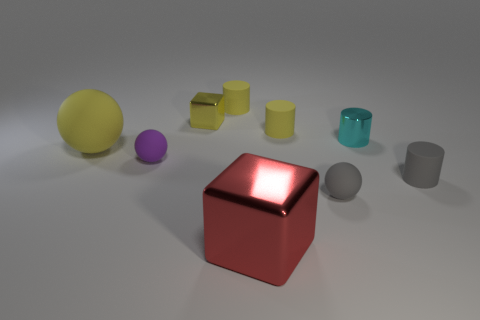There is a yellow shiny object; are there any tiny spheres in front of it?
Your answer should be compact. Yes. There is a matte object that is in front of the small cylinder that is in front of the tiny purple rubber ball; what is its size?
Offer a very short reply. Small. Is the number of metallic things that are in front of the small gray ball the same as the number of metallic things right of the gray rubber cylinder?
Give a very brief answer. No. There is a big object that is in front of the purple rubber ball; are there any yellow cylinders that are left of it?
Your answer should be compact. Yes. There is a gray thing that is to the left of the tiny matte cylinder to the right of the gray rubber sphere; how many yellow metallic blocks are in front of it?
Your answer should be very brief. 0. Is the number of cyan shiny cylinders less than the number of big things?
Offer a very short reply. Yes. Do the tiny yellow object that is right of the big red metallic object and the yellow metallic object behind the small gray ball have the same shape?
Provide a short and direct response. No. What is the color of the large rubber ball?
Give a very brief answer. Yellow. How many rubber things are tiny cyan things or tiny red spheres?
Keep it short and to the point. 0. There is a large object that is the same shape as the tiny purple matte thing; what is its color?
Provide a short and direct response. Yellow. 